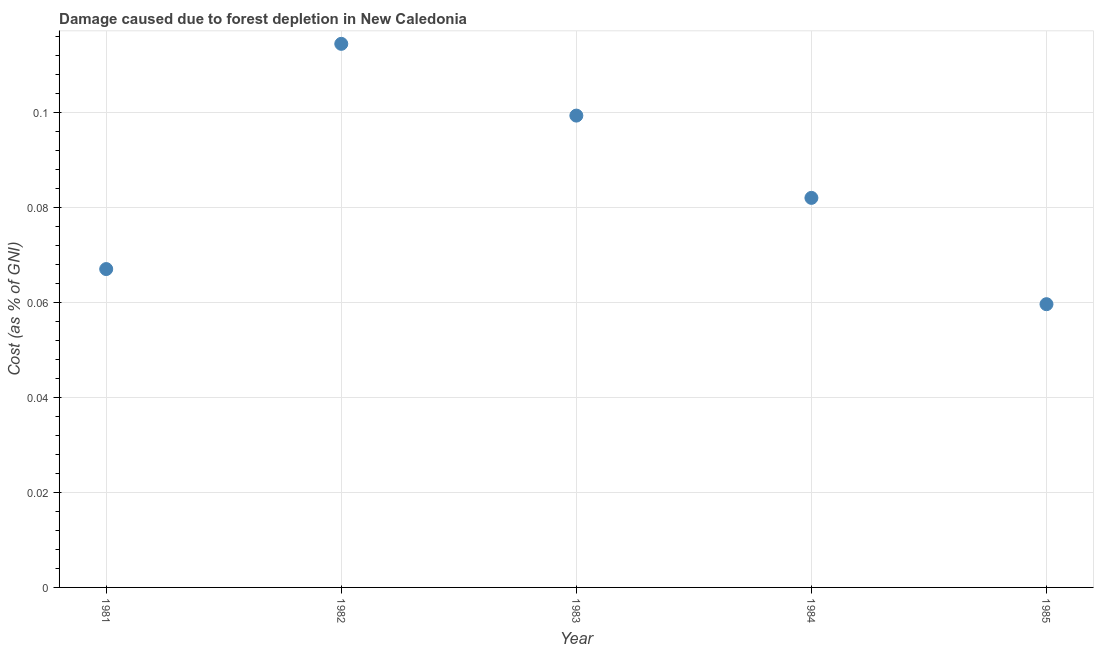What is the damage caused due to forest depletion in 1981?
Your answer should be very brief. 0.07. Across all years, what is the maximum damage caused due to forest depletion?
Your response must be concise. 0.11. Across all years, what is the minimum damage caused due to forest depletion?
Give a very brief answer. 0.06. In which year was the damage caused due to forest depletion minimum?
Offer a very short reply. 1985. What is the sum of the damage caused due to forest depletion?
Give a very brief answer. 0.42. What is the difference between the damage caused due to forest depletion in 1982 and 1984?
Provide a succinct answer. 0.03. What is the average damage caused due to forest depletion per year?
Ensure brevity in your answer.  0.08. What is the median damage caused due to forest depletion?
Keep it short and to the point. 0.08. In how many years, is the damage caused due to forest depletion greater than 0.028 %?
Your answer should be compact. 5. What is the ratio of the damage caused due to forest depletion in 1984 to that in 1985?
Ensure brevity in your answer.  1.38. Is the damage caused due to forest depletion in 1981 less than that in 1984?
Your answer should be very brief. Yes. What is the difference between the highest and the second highest damage caused due to forest depletion?
Provide a succinct answer. 0.02. What is the difference between the highest and the lowest damage caused due to forest depletion?
Ensure brevity in your answer.  0.05. How many years are there in the graph?
Offer a terse response. 5. What is the title of the graph?
Make the answer very short. Damage caused due to forest depletion in New Caledonia. What is the label or title of the Y-axis?
Offer a very short reply. Cost (as % of GNI). What is the Cost (as % of GNI) in 1981?
Offer a terse response. 0.07. What is the Cost (as % of GNI) in 1982?
Provide a succinct answer. 0.11. What is the Cost (as % of GNI) in 1983?
Provide a succinct answer. 0.1. What is the Cost (as % of GNI) in 1984?
Your answer should be compact. 0.08. What is the Cost (as % of GNI) in 1985?
Your response must be concise. 0.06. What is the difference between the Cost (as % of GNI) in 1981 and 1982?
Keep it short and to the point. -0.05. What is the difference between the Cost (as % of GNI) in 1981 and 1983?
Give a very brief answer. -0.03. What is the difference between the Cost (as % of GNI) in 1981 and 1984?
Ensure brevity in your answer.  -0.01. What is the difference between the Cost (as % of GNI) in 1981 and 1985?
Offer a very short reply. 0.01. What is the difference between the Cost (as % of GNI) in 1982 and 1983?
Provide a short and direct response. 0.02. What is the difference between the Cost (as % of GNI) in 1982 and 1984?
Ensure brevity in your answer.  0.03. What is the difference between the Cost (as % of GNI) in 1982 and 1985?
Make the answer very short. 0.05. What is the difference between the Cost (as % of GNI) in 1983 and 1984?
Your answer should be very brief. 0.02. What is the difference between the Cost (as % of GNI) in 1983 and 1985?
Offer a very short reply. 0.04. What is the difference between the Cost (as % of GNI) in 1984 and 1985?
Give a very brief answer. 0.02. What is the ratio of the Cost (as % of GNI) in 1981 to that in 1982?
Your answer should be very brief. 0.59. What is the ratio of the Cost (as % of GNI) in 1981 to that in 1983?
Keep it short and to the point. 0.68. What is the ratio of the Cost (as % of GNI) in 1981 to that in 1984?
Provide a succinct answer. 0.82. What is the ratio of the Cost (as % of GNI) in 1981 to that in 1985?
Offer a terse response. 1.12. What is the ratio of the Cost (as % of GNI) in 1982 to that in 1983?
Your response must be concise. 1.15. What is the ratio of the Cost (as % of GNI) in 1982 to that in 1984?
Provide a short and direct response. 1.4. What is the ratio of the Cost (as % of GNI) in 1982 to that in 1985?
Provide a short and direct response. 1.92. What is the ratio of the Cost (as % of GNI) in 1983 to that in 1984?
Provide a succinct answer. 1.21. What is the ratio of the Cost (as % of GNI) in 1983 to that in 1985?
Offer a terse response. 1.67. What is the ratio of the Cost (as % of GNI) in 1984 to that in 1985?
Provide a short and direct response. 1.38. 